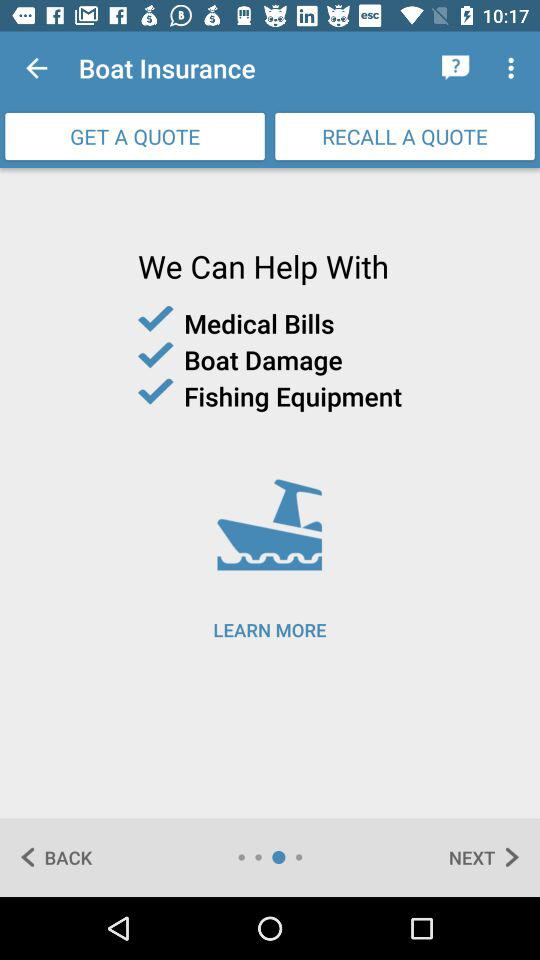How can I get help?
When the provided information is insufficient, respond with <no answer>. <no answer> 